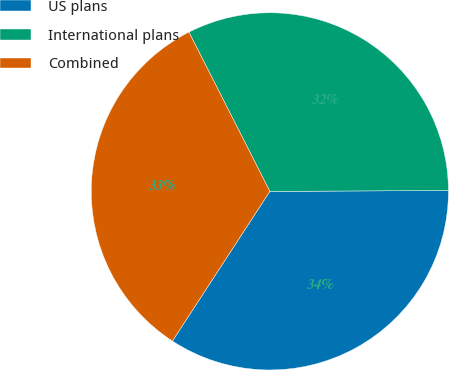Convert chart. <chart><loc_0><loc_0><loc_500><loc_500><pie_chart><fcel>US plans<fcel>International plans<fcel>Combined<nl><fcel>34.26%<fcel>32.41%<fcel>33.33%<nl></chart> 